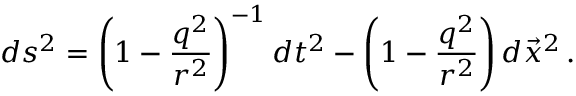<formula> <loc_0><loc_0><loc_500><loc_500>d s ^ { 2 } = \left ( 1 - \frac { q ^ { 2 } } { r ^ { 2 } } \right ) ^ { - 1 } d t ^ { 2 } - \left ( 1 - \frac { q ^ { 2 } } { r ^ { 2 } } \right ) d \vec { x } ^ { 2 } \, .</formula> 